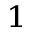Convert formula to latex. <formula><loc_0><loc_0><loc_500><loc_500>^ { 1 }</formula> 